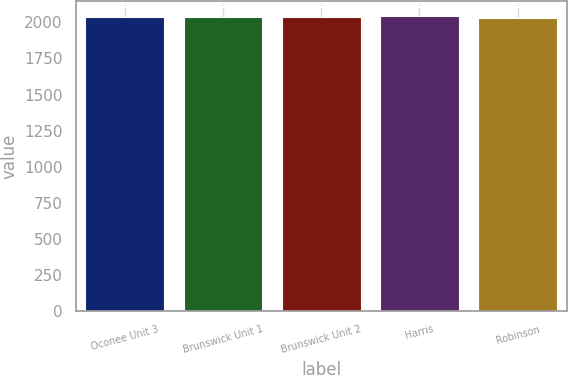Convert chart to OTSL. <chart><loc_0><loc_0><loc_500><loc_500><bar_chart><fcel>Oconee Unit 3<fcel>Brunswick Unit 1<fcel>Brunswick Unit 2<fcel>Harris<fcel>Robinson<nl><fcel>2034<fcel>2037.2<fcel>2035.6<fcel>2046<fcel>2030<nl></chart> 